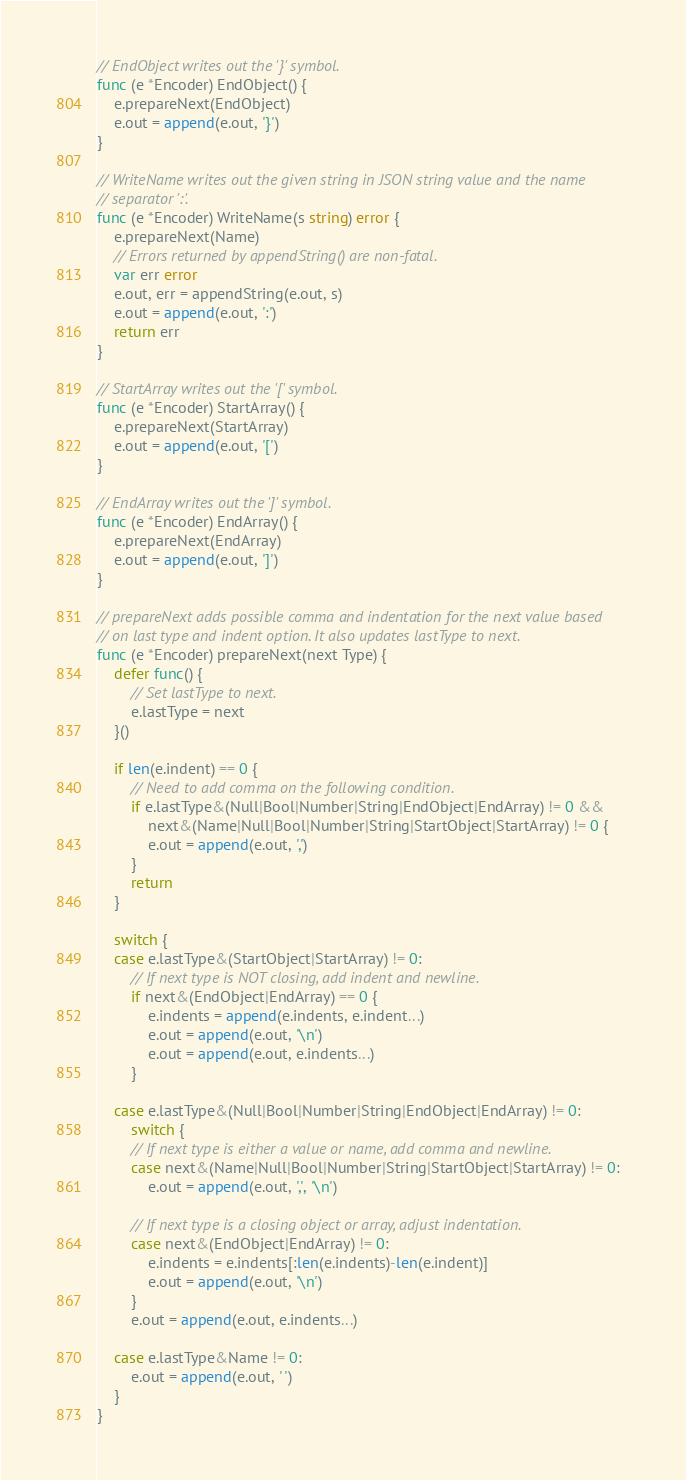Convert code to text. <code><loc_0><loc_0><loc_500><loc_500><_Go_>// EndObject writes out the '}' symbol.
func (e *Encoder) EndObject() {
	e.prepareNext(EndObject)
	e.out = append(e.out, '}')
}

// WriteName writes out the given string in JSON string value and the name
// separator ':'.
func (e *Encoder) WriteName(s string) error {
	e.prepareNext(Name)
	// Errors returned by appendString() are non-fatal.
	var err error
	e.out, err = appendString(e.out, s)
	e.out = append(e.out, ':')
	return err
}

// StartArray writes out the '[' symbol.
func (e *Encoder) StartArray() {
	e.prepareNext(StartArray)
	e.out = append(e.out, '[')
}

// EndArray writes out the ']' symbol.
func (e *Encoder) EndArray() {
	e.prepareNext(EndArray)
	e.out = append(e.out, ']')
}

// prepareNext adds possible comma and indentation for the next value based
// on last type and indent option. It also updates lastType to next.
func (e *Encoder) prepareNext(next Type) {
	defer func() {
		// Set lastType to next.
		e.lastType = next
	}()

	if len(e.indent) == 0 {
		// Need to add comma on the following condition.
		if e.lastType&(Null|Bool|Number|String|EndObject|EndArray) != 0 &&
			next&(Name|Null|Bool|Number|String|StartObject|StartArray) != 0 {
			e.out = append(e.out, ',')
		}
		return
	}

	switch {
	case e.lastType&(StartObject|StartArray) != 0:
		// If next type is NOT closing, add indent and newline.
		if next&(EndObject|EndArray) == 0 {
			e.indents = append(e.indents, e.indent...)
			e.out = append(e.out, '\n')
			e.out = append(e.out, e.indents...)
		}

	case e.lastType&(Null|Bool|Number|String|EndObject|EndArray) != 0:
		switch {
		// If next type is either a value or name, add comma and newline.
		case next&(Name|Null|Bool|Number|String|StartObject|StartArray) != 0:
			e.out = append(e.out, ',', '\n')

		// If next type is a closing object or array, adjust indentation.
		case next&(EndObject|EndArray) != 0:
			e.indents = e.indents[:len(e.indents)-len(e.indent)]
			e.out = append(e.out, '\n')
		}
		e.out = append(e.out, e.indents...)

	case e.lastType&Name != 0:
		e.out = append(e.out, ' ')
	}
}
</code> 